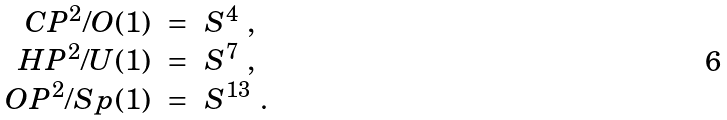Convert formula to latex. <formula><loc_0><loc_0><loc_500><loc_500>\begin{array} { r c l } C P ^ { 2 } / O ( 1 ) & = & S ^ { 4 } \ , \\ H P ^ { 2 } / U ( 1 ) & = & S ^ { 7 } \ , \\ O P ^ { 2 } / S p ( 1 ) & = & S ^ { 1 3 } \ . \end{array}</formula> 